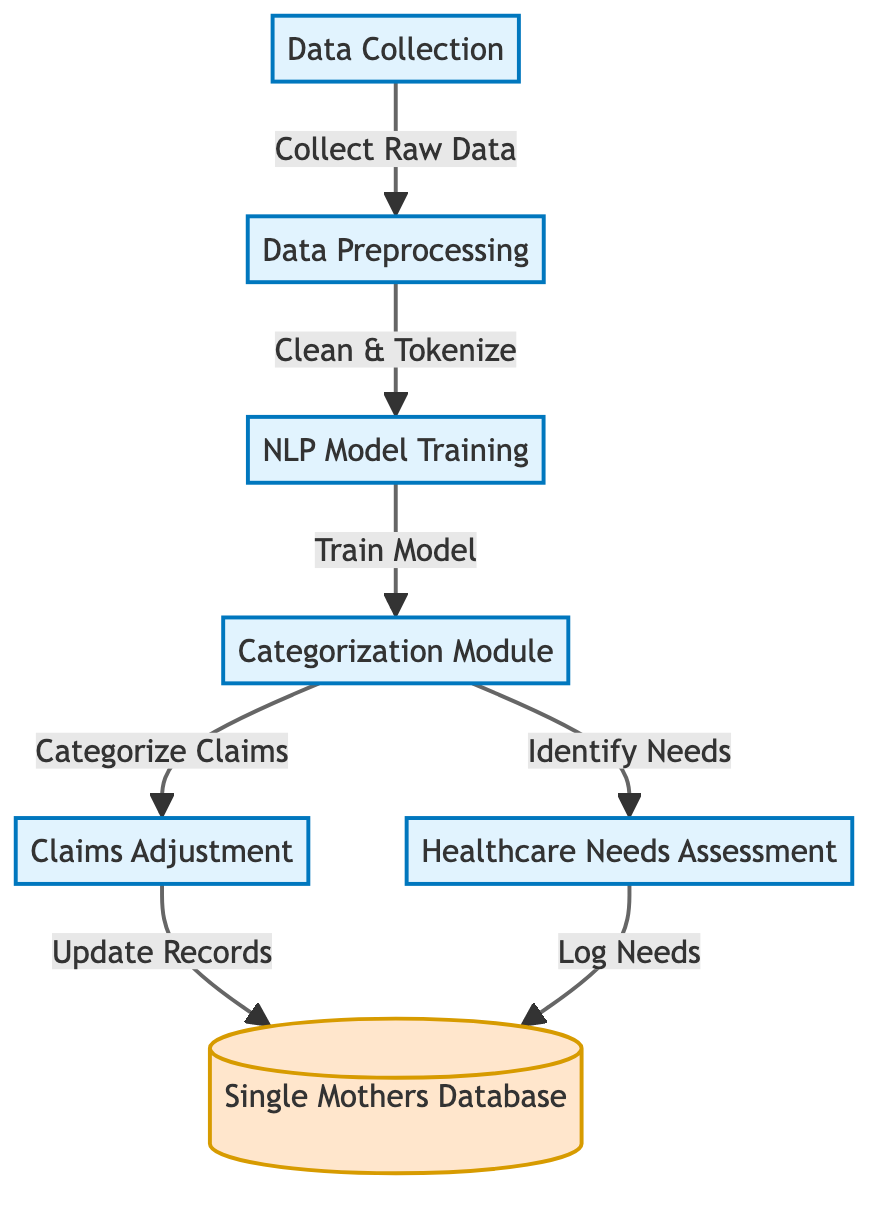What is the first step in the diagram? The first step shown in the diagram is "Data Collection," where raw data is collected before any processing takes place.
Answer: Data Collection How many main processes are indicated in the diagram? There are six main processes outlined in the diagram, which are Data Collection, Data Preprocessing, NLP Model Training, Categorization Module, Claims Adjustment, and Healthcare Needs Assessment.
Answer: Six What does the "NLP Model Training" node feed into next? The "NLP Model Training" node feeds into the "Categorization Module," indicating that once the NLP model is trained, it is used for categorizing claims.
Answer: Categorization Module What type of data does the "Single Mothers Database" represent? The "Single Mothers Database" represents an output database where information related to claims adjustments and healthcare needs is logged.
Answer: Output database Which module is responsible for identifying healthcare needs? The "Categorization Module" is tasked with identifying healthcare needs, highlighting its dual role in processing both claims and needs.
Answer: Categorization Module What is the relationship between "Claims Adjustment" and the "Single Mothers Database"? The "Claims Adjustment" process updates records in the "Single Mothers Database," establishing a direct connection where claims data is stored.
Answer: Update Records Explain how claims are categorized in the diagram. Claims are categorized through the "Categorization Module," which receives input from the "NLP Model Training." This module processes the data and then directs the categorized claims to the "Claims Adjustment" as well as identifying healthcare needs.
Answer: Through the Categorization Module Which process comes directly after data cleaning and tokenization? After data cleaning and tokenization, the next process is "NLP Model Training," which indicates that preprocessed data is immediately used to train the NLP model.
Answer: NLP Model Training What are the two outputs of the "Categorization Module"? The "Categorization Module" has two outputs: one directing to "Claims Adjustment" and another to "Healthcare Needs Assessment," managing both claims processing and needs identification simultaneously.
Answer: Claims Adjustment and Healthcare Needs Assessment 